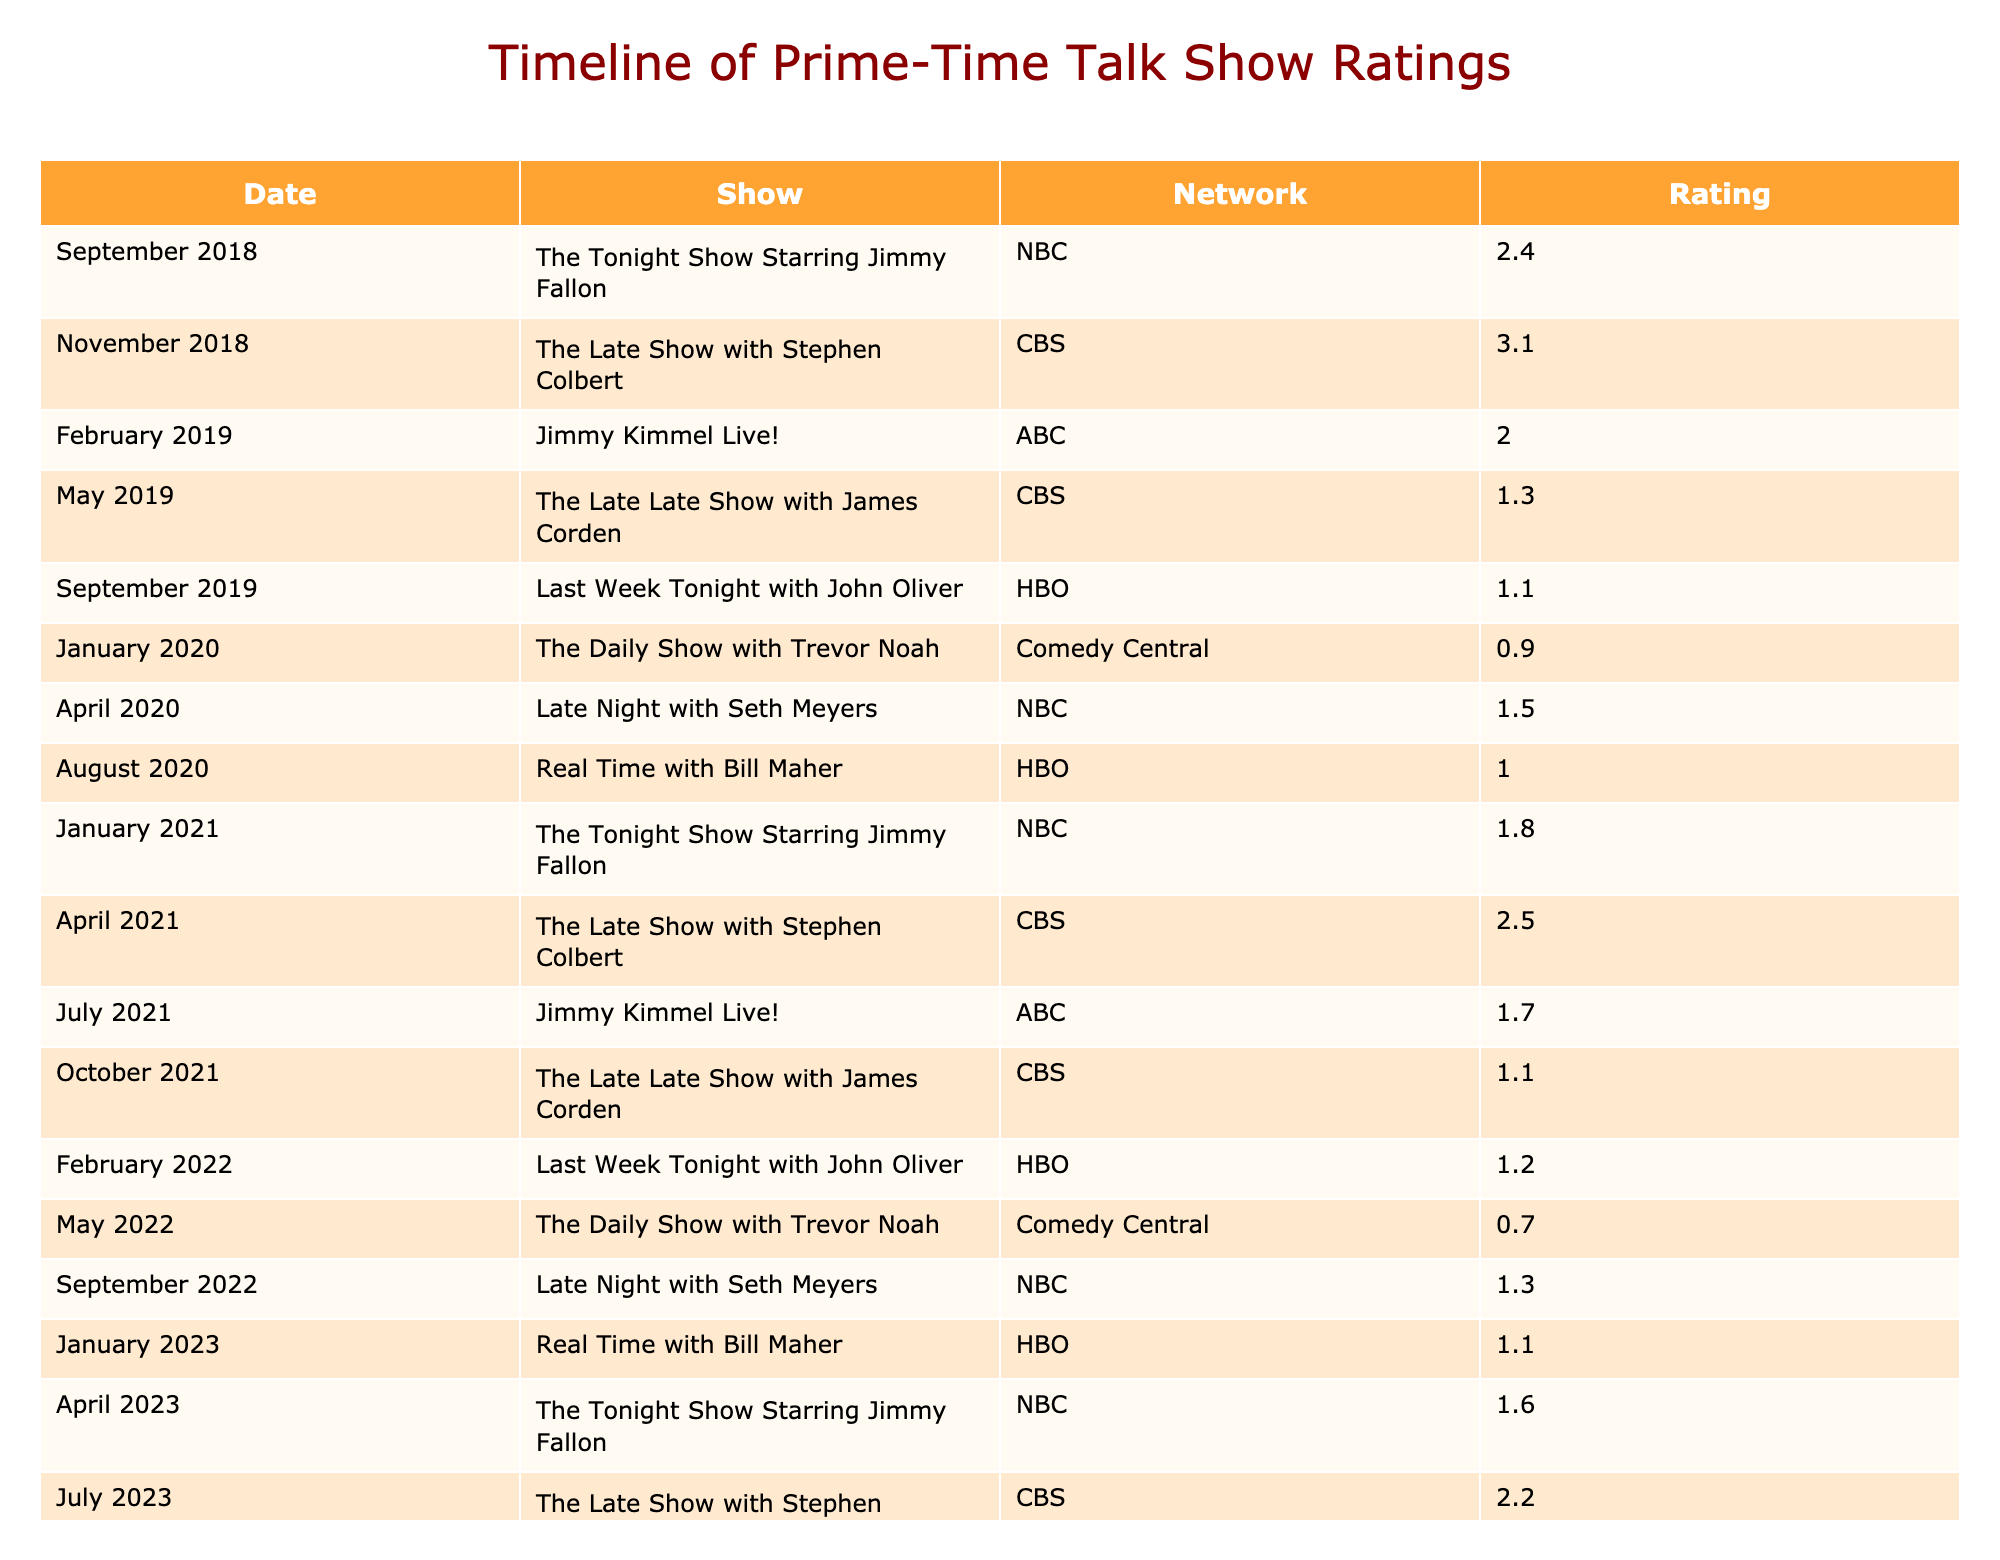What was the rating for The Tonight Show Starring Jimmy Fallon in April 2023? By locating the row for April 2023 and identifying the corresponding rating for The Tonight Show Starring Jimmy Fallon, we find that the show had a rating of 1.6.
Answer: 1.6 What show had the highest rating in 2018? By examining the rows for the year 2018, The Late Show with Stephen Colbert had the highest rating of 3.1 in November.
Answer: 3.1 What was the average rating for The Late Show with Stephen Colbert over the timeline? The ratings for The Late Show with Stephen Colbert are 3.1 (Nov 2018), 2.5 (Apr 2021), and 2.2 (Jul 2023). Summing these values gives 3.1 + 2.5 + 2.2 = 7.8, and dividing by 3 shows the average rating is 7.8 / 3 = 2.6.
Answer: 2.6 Did the rating for Last Week Tonight with John Oliver increase from September 2019 to February 2022? The rating for Last Week Tonight with John Oliver in September 2019 was 1.1, while in February 2022 it was 1.2. Since 1.2 is greater than 1.1, the rating did indeed increase.
Answer: Yes Which show consistently had lower ratings than 2.0 throughout the timeline? By reviewing the ratings across all entries, The Daily Show with Trevor Noah (0.9 in Jan 2020 and 0.7 in May 2022), and Late Late Show with James Corden (1.3 in May 2019 and 1.1 in Oct 2021) consistently had ratings below 2.0.
Answer: The Daily Show with Trevor Noah and Late Late Show with James Corden What was the lowest rating recorded in 2022? Looking at the rows for 2022, the ratings were 1.2 (Feb), 0.7 (May), and 1.3 (Sep). The lowest among these is 0.7 in May 2022.
Answer: 0.7 How many different shows had ratings of 1.0 or less across the timeline? The shows that received ratings of 1.0 or less are The Daily Show with Trevor Noah (0.9 in Jan 2020) and Real Time with Bill Maher (1.0 in Aug 2020). This totals 2 unique shows.
Answer: 2 What show had the lowest rating in April 2020, and what was that rating? In April 2020, Late Night with Seth Meyers was the only show listed, with a rating of 1.5. Thus, it has the lowest rating for that month.
Answer: 1.5 Which two months in 2021 showed a decrease in the rating for The Tonight Show Starring Jimmy Fallon compared to previous months? The rating for The Tonight Show Starring Jimmy Fallon was 2.4 in Sep 2018, dropping to 1.8 in Jan 2021 and continuing to fall to 1.6 in Apr 2023. This shows the month’s comparisons: 2.4 (last Sept) to 1.8 (this Jan) in 2021, and again to 1.6 in Apr 2023, indicating a decrease.
Answer: January and April 2021 